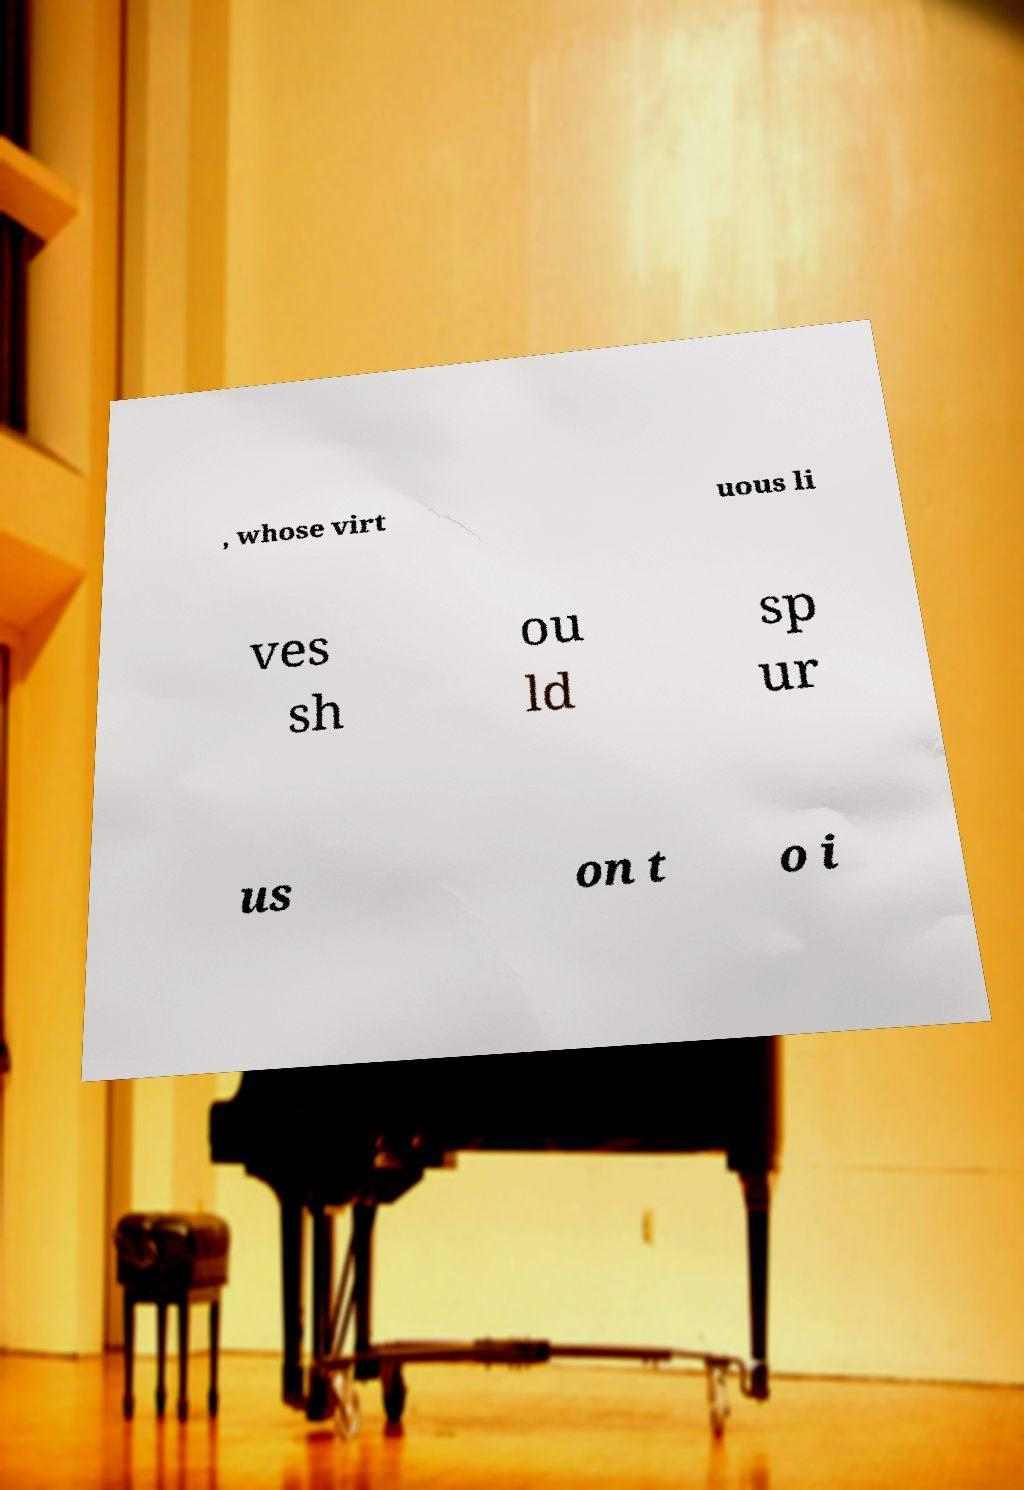Could you extract and type out the text from this image? , whose virt uous li ves sh ou ld sp ur us on t o i 